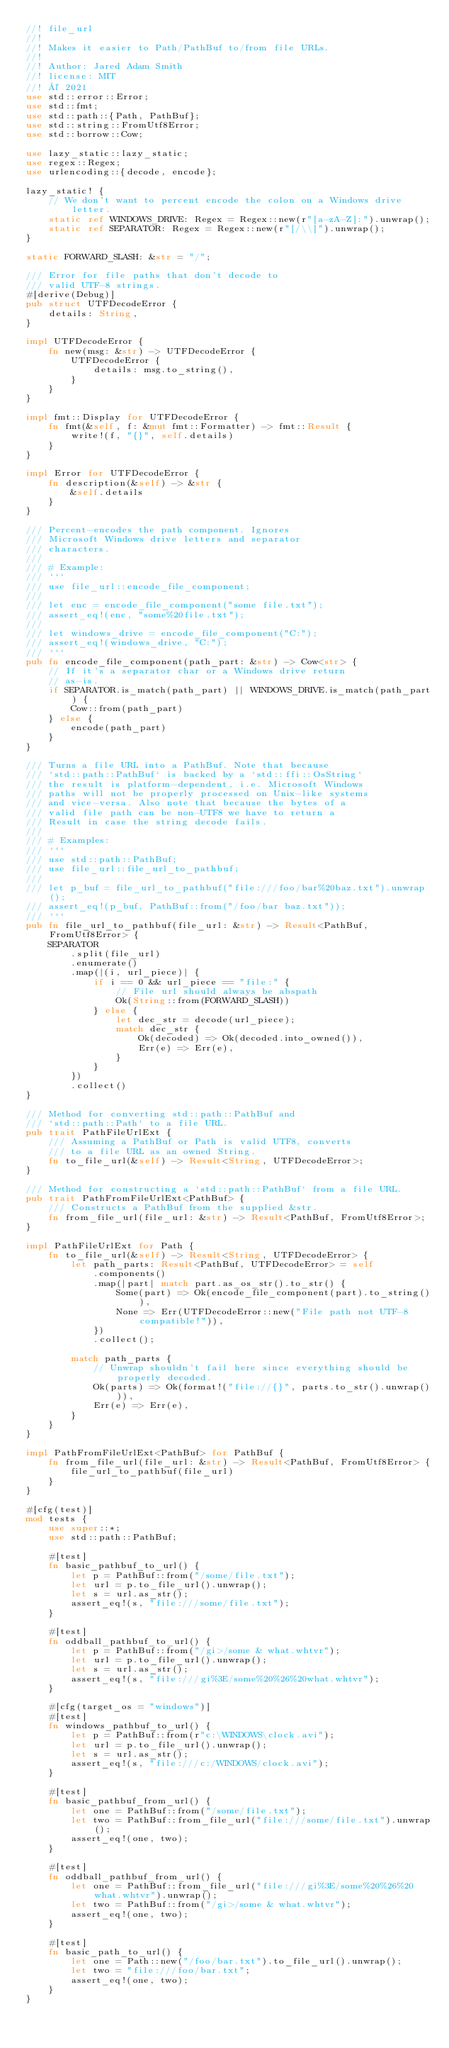Convert code to text. <code><loc_0><loc_0><loc_500><loc_500><_Rust_>//! file_url
//!
//! Makes it easier to Path/PathBuf to/from file URLs.
//!
//! Author: Jared Adam Smith
//! license: MIT
//! © 2021
use std::error::Error;
use std::fmt;
use std::path::{Path, PathBuf};
use std::string::FromUtf8Error;
use std::borrow::Cow;

use lazy_static::lazy_static;
use regex::Regex;
use urlencoding::{decode, encode};

lazy_static! {
    // We don't want to percent encode the colon on a Windows drive letter.
    static ref WINDOWS_DRIVE: Regex = Regex::new(r"[a-zA-Z]:").unwrap();
    static ref SEPARATOR: Regex = Regex::new(r"[/\\]").unwrap();
}

static FORWARD_SLASH: &str = "/";

/// Error for file paths that don't decode to
/// valid UTF-8 strings.
#[derive(Debug)]
pub struct UTFDecodeError {
    details: String,
}

impl UTFDecodeError {
    fn new(msg: &str) -> UTFDecodeError {
        UTFDecodeError {
            details: msg.to_string(),
        }
    }
}

impl fmt::Display for UTFDecodeError {
    fn fmt(&self, f: &mut fmt::Formatter) -> fmt::Result {
        write!(f, "{}", self.details)
    }
}

impl Error for UTFDecodeError {
    fn description(&self) -> &str {
        &self.details
    }
}

/// Percent-encodes the path component. Ignores
/// Microsoft Windows drive letters and separator
/// characters.
///
/// # Example:
/// ```
/// use file_url::encode_file_component;
///
/// let enc = encode_file_component("some file.txt");
/// assert_eq!(enc, "some%20file.txt");
///
/// let windows_drive = encode_file_component("C:");
/// assert_eq!(windows_drive, "C:");
/// ```
pub fn encode_file_component(path_part: &str) -> Cow<str> {
    // If it's a separator char or a Windows drive return
    // as-is.
    if SEPARATOR.is_match(path_part) || WINDOWS_DRIVE.is_match(path_part) {
        Cow::from(path_part)
    } else {
        encode(path_part)
    }
}

/// Turns a file URL into a PathBuf. Note that because
/// `std::path::PathBuf` is backed by a `std::ffi::OsString`
/// the result is platform-dependent, i.e. Microsoft Windows
/// paths will not be properly processed on Unix-like systems
/// and vice-versa. Also note that because the bytes of a
/// valid file path can be non-UTF8 we have to return a
/// Result in case the string decode fails.
///
/// # Examples:
/// ```
/// use std::path::PathBuf;
/// use file_url::file_url_to_pathbuf;
///
/// let p_buf = file_url_to_pathbuf("file:///foo/bar%20baz.txt").unwrap();
/// assert_eq!(p_buf, PathBuf::from("/foo/bar baz.txt"));
/// ```
pub fn file_url_to_pathbuf(file_url: &str) -> Result<PathBuf, FromUtf8Error> {
    SEPARATOR
        .split(file_url)
        .enumerate()
        .map(|(i, url_piece)| {
            if i == 0 && url_piece == "file:" {
                // File url should always be abspath
                Ok(String::from(FORWARD_SLASH))
            } else {
                let dec_str = decode(url_piece);
                match dec_str {
                    Ok(decoded) => Ok(decoded.into_owned()),
                    Err(e) => Err(e),
                }
            }
        })
        .collect()
}

/// Method for converting std::path::PathBuf and
/// `std::path::Path` to a file URL.
pub trait PathFileUrlExt {
    /// Assuming a PathBuf or Path is valid UTF8, converts
    /// to a file URL as an owned String.
    fn to_file_url(&self) -> Result<String, UTFDecodeError>;
}

/// Method for constructing a `std::path::PathBuf` from a file URL.
pub trait PathFromFileUrlExt<PathBuf> {
    /// Constructs a PathBuf from the supplied &str.
    fn from_file_url(file_url: &str) -> Result<PathBuf, FromUtf8Error>;
}

impl PathFileUrlExt for Path {
    fn to_file_url(&self) -> Result<String, UTFDecodeError> {
        let path_parts: Result<PathBuf, UTFDecodeError> = self
            .components()
            .map(|part| match part.as_os_str().to_str() {
                Some(part) => Ok(encode_file_component(part).to_string()),
                None => Err(UTFDecodeError::new("File path not UTF-8 compatible!")),
            })
            .collect();

        match path_parts {
            // Unwrap shouldn't fail here since everything should be properly decoded.
            Ok(parts) => Ok(format!("file://{}", parts.to_str().unwrap())),
            Err(e) => Err(e),
        }
    }
}

impl PathFromFileUrlExt<PathBuf> for PathBuf {
    fn from_file_url(file_url: &str) -> Result<PathBuf, FromUtf8Error> {
        file_url_to_pathbuf(file_url)
    }
}

#[cfg(test)]
mod tests {
    use super::*;
    use std::path::PathBuf;

    #[test]
    fn basic_pathbuf_to_url() {
        let p = PathBuf::from("/some/file.txt");
        let url = p.to_file_url().unwrap();
        let s = url.as_str();
        assert_eq!(s, "file:///some/file.txt");
    }

    #[test]
    fn oddball_pathbuf_to_url() {
        let p = PathBuf::from("/gi>/some & what.whtvr");
        let url = p.to_file_url().unwrap();
        let s = url.as_str();
        assert_eq!(s, "file:///gi%3E/some%20%26%20what.whtvr");
    }

    #[cfg(target_os = "windows")]
    #[test]
    fn windows_pathbuf_to_url() {
        let p = PathBuf::from(r"c:\WINDOWS\clock.avi");
        let url = p.to_file_url().unwrap();
        let s = url.as_str();
        assert_eq!(s, "file:///c:/WINDOWS/clock.avi");
    }

    #[test]
    fn basic_pathbuf_from_url() {
        let one = PathBuf::from("/some/file.txt");
        let two = PathBuf::from_file_url("file:///some/file.txt").unwrap();
        assert_eq!(one, two);
    }

    #[test]
    fn oddball_pathbuf_from_url() {
        let one = PathBuf::from_file_url("file:///gi%3E/some%20%26%20what.whtvr").unwrap();
        let two = PathBuf::from("/gi>/some & what.whtvr");
        assert_eq!(one, two);
    }

    #[test]
    fn basic_path_to_url() {
        let one = Path::new("/foo/bar.txt").to_file_url().unwrap();
        let two = "file:///foo/bar.txt";
        assert_eq!(one, two);
    }
}
</code> 